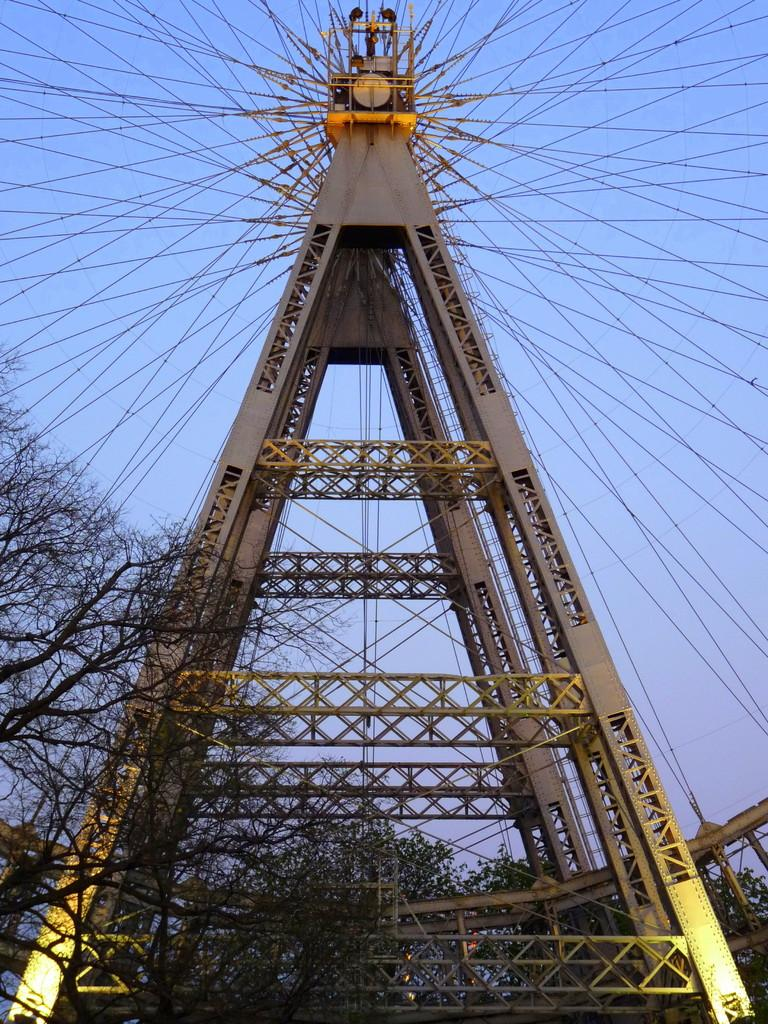What is the main structure in the center of the image? There is a tower in the center of the image. What else can be seen in the image besides the tower? There are wires and a few other objects in the image. What can be seen in the background of the image? The sky and trees are visible in the background of the image. What type of brass instrument is being played by the person on top of the tower in the image? There is no person or brass instrument present on top of the tower in the image. 